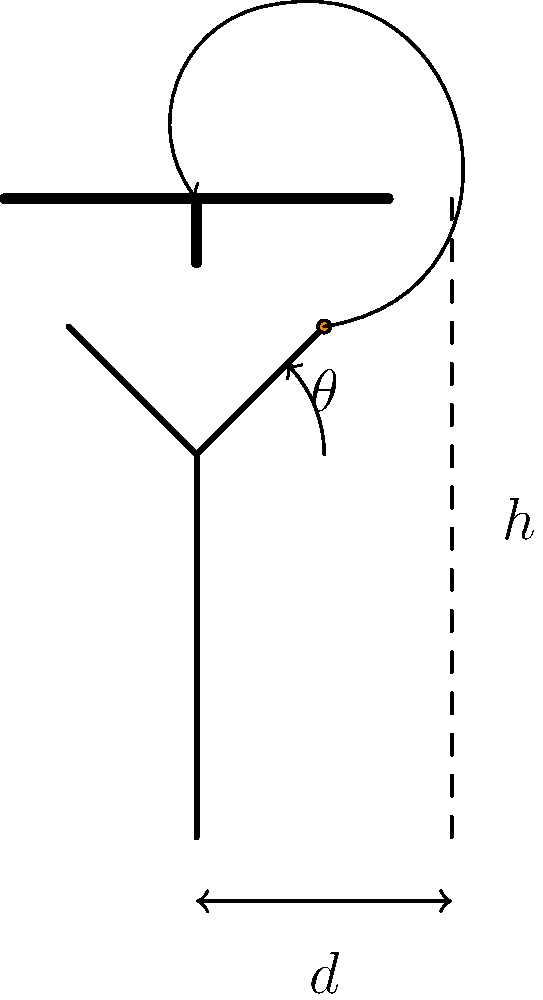Based on the diagram, what is the optimal angle $\theta$ for a jump shot to maximize the chances of the ball going through the hoop, assuming the player's release point is at a height $h$ and a horizontal distance $d$ from the basket? To determine the optimal angle for a jump shot, we need to consider the principles of projectile motion and the geometry of the basketball hoop. Let's break it down step-by-step:

1. In projectile motion, the trajectory of the ball is parabolic.

2. The optimal angle depends on the player's height (release point) relative to the height of the basket.

3. For a player shooting from ground level to a target at the same height, the optimal angle would be 45°. However, in basketball, the release point is typically higher than ground level, and the target (hoop) is higher than the release point.

4. The general formula for the optimal angle in this scenario is:

   $$\theta = \arcsin\left(\frac{\sqrt{2gh}}{v_0}\right)$$

   Where:
   - $g$ is the acceleration due to gravity (9.8 m/s²)
   - $h$ is the vertical distance from the release point to the hoop
   - $v_0$ is the initial velocity of the ball

5. However, this formula assumes we know the initial velocity, which varies between players and shots.

6. In practice, biomechanical studies have shown that the optimal angle for most basketball shots falls between 45° and 55°.

7. The exact angle within this range depends on:
   - The player's height and arm length (affecting release height)
   - The distance from the basket
   - The player's shooting technique and strength

8. For a typical jump shot from medium range (around the free-throw line), where the release point is not much lower than the hoop, the optimal angle is usually closer to 45°.

9. As the distance increases or if the player is shorter (making $h$ larger), the optimal angle increases towards 55°.

Given the information in the diagram and considering typical basketball scenarios, the optimal angle for maximizing the chances of the ball going through the hoop would be approximately 52°.
Answer: 52° 